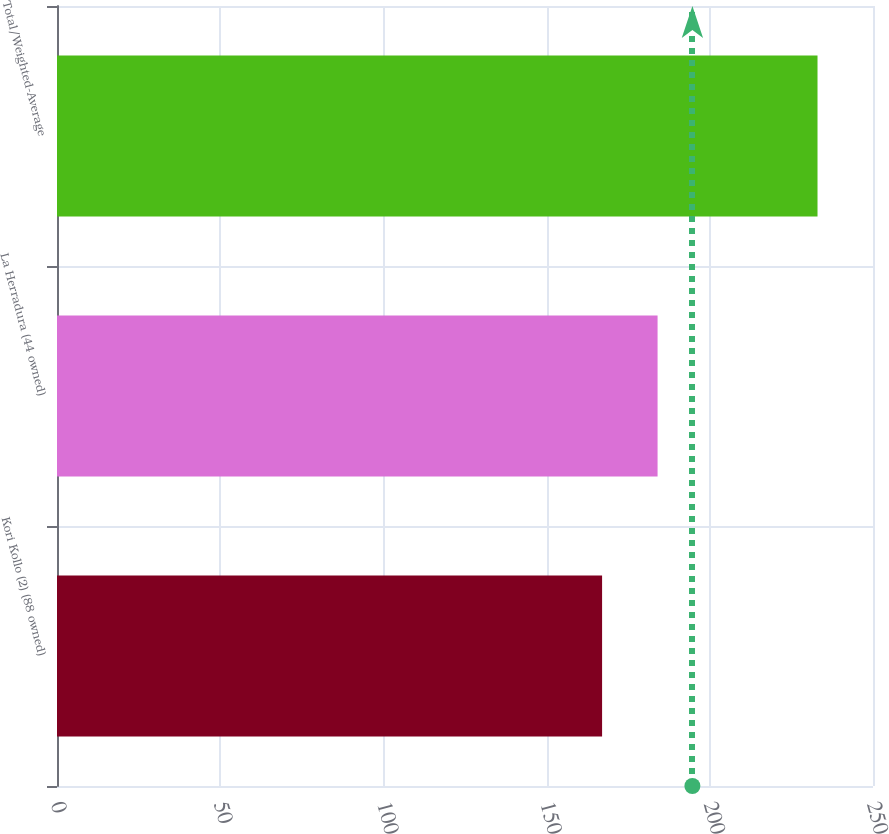Convert chart. <chart><loc_0><loc_0><loc_500><loc_500><bar_chart><fcel>Kori Kollo (2) (88 owned)<fcel>La Herradura (44 owned)<fcel>Total/Weighted-Average<nl><fcel>167<fcel>184<fcel>233<nl></chart> 